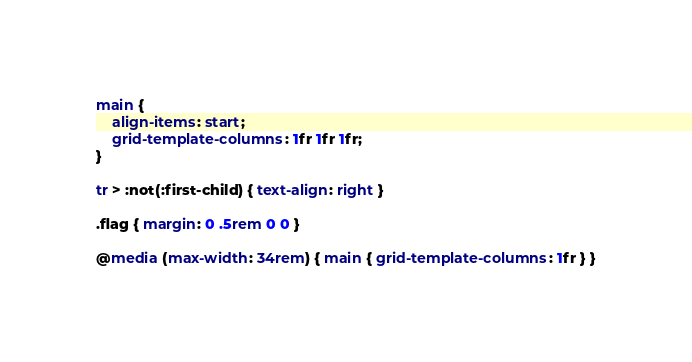<code> <loc_0><loc_0><loc_500><loc_500><_CSS_>main {
    align-items: start;
    grid-template-columns: 1fr 1fr 1fr;
}

tr > :not(:first-child) { text-align: right }

.flag { margin: 0 .5rem 0 0 }

@media (max-width: 34rem) { main { grid-template-columns: 1fr } }
</code> 